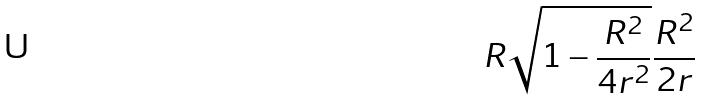<formula> <loc_0><loc_0><loc_500><loc_500>R \sqrt { 1 - \frac { R ^ { 2 } } { 4 r ^ { 2 } } } \frac { R ^ { 2 } } { 2 r }</formula> 